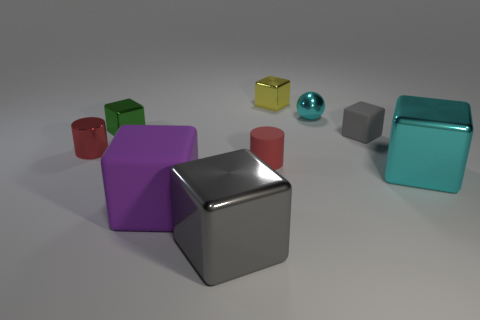What number of other objects are the same material as the large gray object?
Ensure brevity in your answer.  5. Are any green matte cylinders visible?
Your answer should be very brief. No. Are the cyan thing that is in front of the red matte object and the green thing made of the same material?
Provide a succinct answer. Yes. There is a yellow thing that is the same shape as the big purple matte object; what material is it?
Provide a succinct answer. Metal. There is a tiny thing that is the same color as the small metallic cylinder; what is it made of?
Keep it short and to the point. Rubber. Is the number of large cyan blocks less than the number of metal blocks?
Your answer should be very brief. Yes. Is the color of the large object that is right of the big gray metallic block the same as the small matte cube?
Give a very brief answer. No. There is another big cube that is the same material as the large cyan cube; what is its color?
Make the answer very short. Gray. Is the gray rubber thing the same size as the metal ball?
Keep it short and to the point. Yes. What is the material of the large cyan block?
Provide a succinct answer. Metal. 